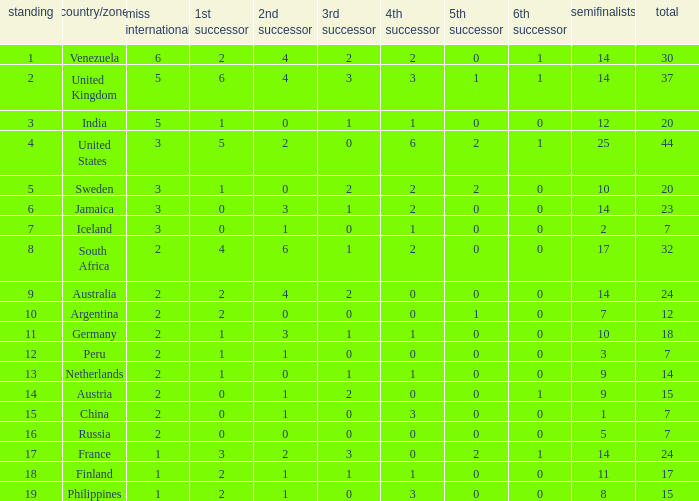What is Venezuela's total rank? 30.0. 